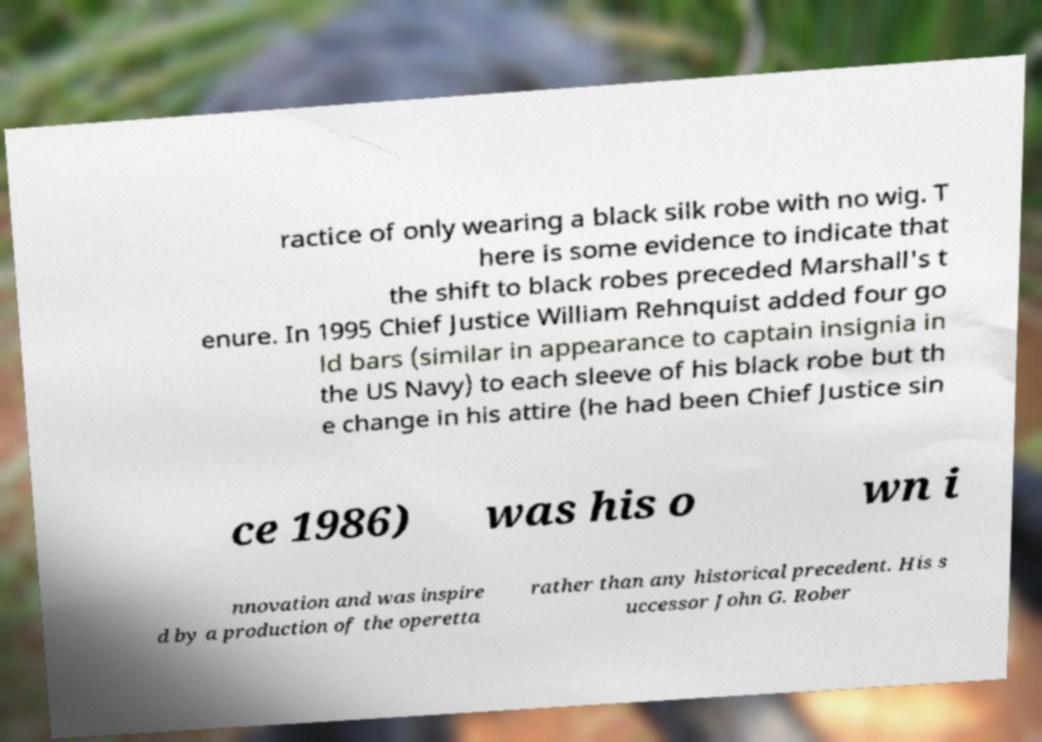Could you extract and type out the text from this image? ractice of only wearing a black silk robe with no wig. T here is some evidence to indicate that the shift to black robes preceded Marshall's t enure. In 1995 Chief Justice William Rehnquist added four go ld bars (similar in appearance to captain insignia in the US Navy) to each sleeve of his black robe but th e change in his attire (he had been Chief Justice sin ce 1986) was his o wn i nnovation and was inspire d by a production of the operetta rather than any historical precedent. His s uccessor John G. Rober 